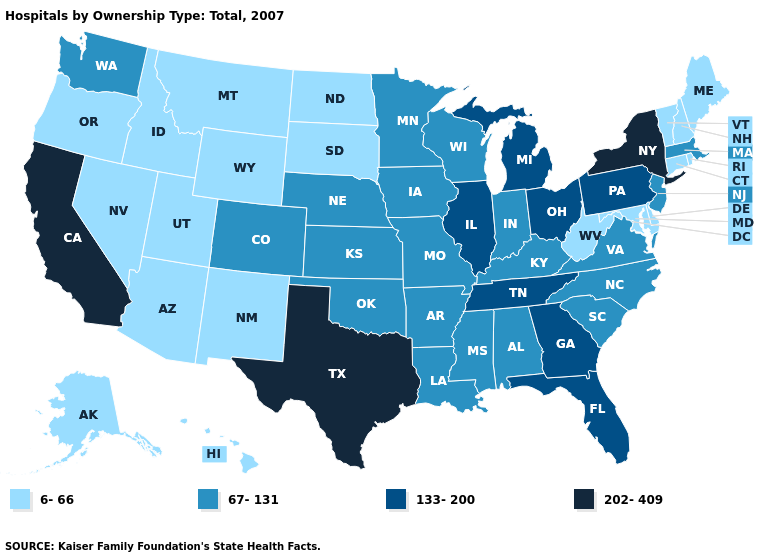Name the states that have a value in the range 67-131?
Concise answer only. Alabama, Arkansas, Colorado, Indiana, Iowa, Kansas, Kentucky, Louisiana, Massachusetts, Minnesota, Mississippi, Missouri, Nebraska, New Jersey, North Carolina, Oklahoma, South Carolina, Virginia, Washington, Wisconsin. Among the states that border North Dakota , does Minnesota have the highest value?
Quick response, please. Yes. Does Colorado have the lowest value in the West?
Quick response, please. No. What is the lowest value in the West?
Answer briefly. 6-66. Does California have the lowest value in the USA?
Answer briefly. No. Does Tennessee have the highest value in the USA?
Write a very short answer. No. Which states hav the highest value in the Northeast?
Short answer required. New York. Name the states that have a value in the range 67-131?
Concise answer only. Alabama, Arkansas, Colorado, Indiana, Iowa, Kansas, Kentucky, Louisiana, Massachusetts, Minnesota, Mississippi, Missouri, Nebraska, New Jersey, North Carolina, Oklahoma, South Carolina, Virginia, Washington, Wisconsin. What is the value of Michigan?
Give a very brief answer. 133-200. Name the states that have a value in the range 202-409?
Keep it brief. California, New York, Texas. Name the states that have a value in the range 202-409?
Answer briefly. California, New York, Texas. Name the states that have a value in the range 6-66?
Answer briefly. Alaska, Arizona, Connecticut, Delaware, Hawaii, Idaho, Maine, Maryland, Montana, Nevada, New Hampshire, New Mexico, North Dakota, Oregon, Rhode Island, South Dakota, Utah, Vermont, West Virginia, Wyoming. Does Nevada have the lowest value in the USA?
Concise answer only. Yes. Name the states that have a value in the range 202-409?
Answer briefly. California, New York, Texas. 